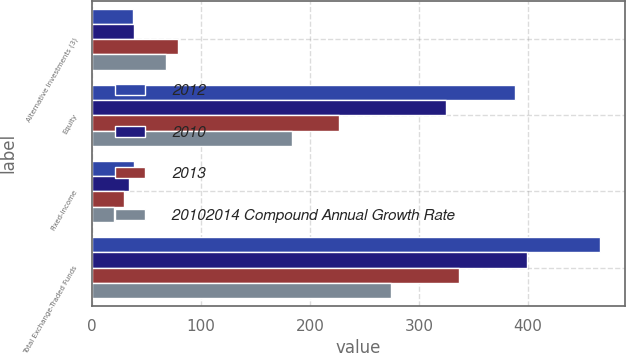Convert chart to OTSL. <chart><loc_0><loc_0><loc_500><loc_500><stacked_bar_chart><ecel><fcel>Alternative Investments (3)<fcel>Equity<fcel>Fixed-income<fcel>Total Exchange-Traded Funds<nl><fcel>2012<fcel>38<fcel>388<fcel>39<fcel>466<nl><fcel>2010<fcel>39<fcel>325<fcel>34<fcel>399<nl><fcel>2013<fcel>79<fcel>227<fcel>30<fcel>337<nl><fcel>20102014 Compound Annual Growth Rate<fcel>68<fcel>184<fcel>20<fcel>274<nl></chart> 